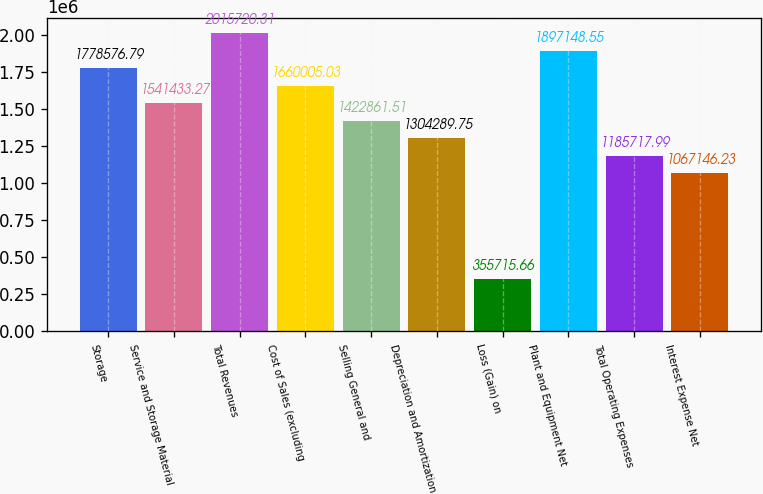Convert chart to OTSL. <chart><loc_0><loc_0><loc_500><loc_500><bar_chart><fcel>Storage<fcel>Service and Storage Material<fcel>Total Revenues<fcel>Cost of Sales (excluding<fcel>Selling General and<fcel>Depreciation and Amortization<fcel>Loss (Gain) on<fcel>Plant and Equipment Net<fcel>Total Operating Expenses<fcel>Interest Expense Net<nl><fcel>1.77858e+06<fcel>1.54143e+06<fcel>2.01572e+06<fcel>1.66001e+06<fcel>1.42286e+06<fcel>1.30429e+06<fcel>355716<fcel>1.89715e+06<fcel>1.18572e+06<fcel>1.06715e+06<nl></chart> 